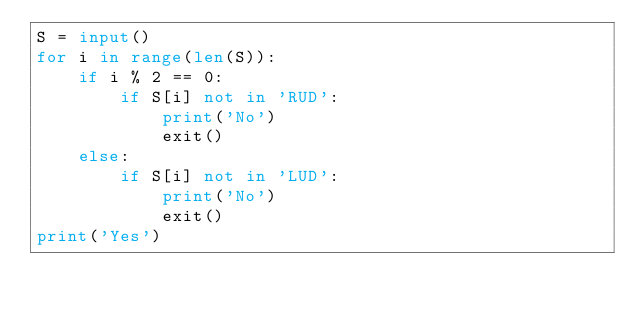<code> <loc_0><loc_0><loc_500><loc_500><_Python_>S = input()
for i in range(len(S)):
    if i % 2 == 0:
        if S[i] not in 'RUD':
            print('No')
            exit()
    else:
        if S[i] not in 'LUD':
            print('No')
            exit()
print('Yes')
</code> 